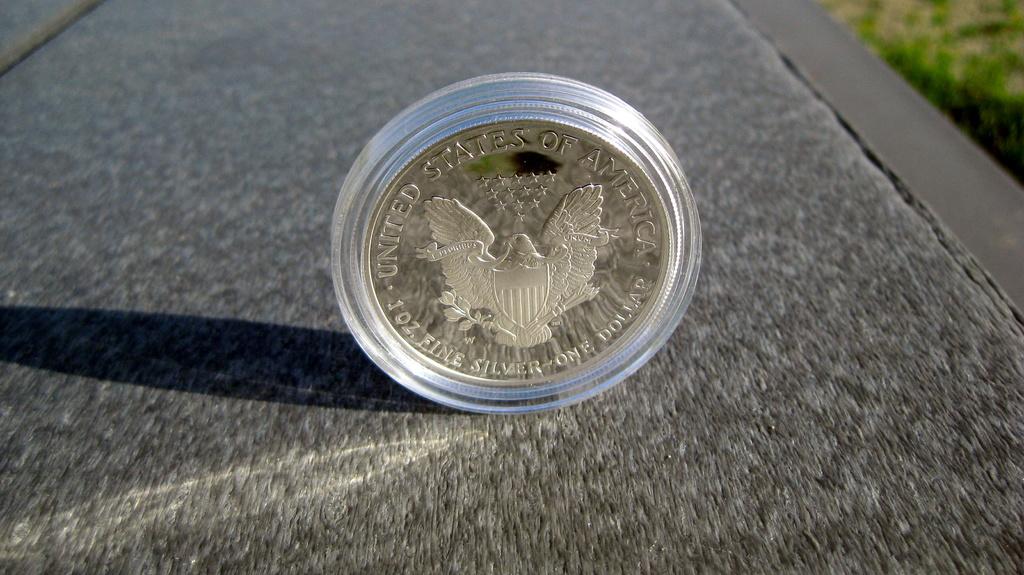What country is this currency from?
Offer a terse response. Usa. What is picture?
Give a very brief answer. Coin. 